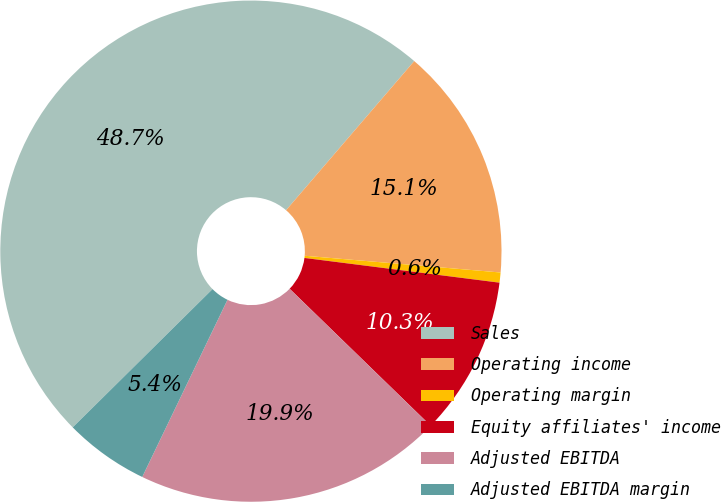Convert chart to OTSL. <chart><loc_0><loc_0><loc_500><loc_500><pie_chart><fcel>Sales<fcel>Operating income<fcel>Operating margin<fcel>Equity affiliates' income<fcel>Adjusted EBITDA<fcel>Adjusted EBITDA margin<nl><fcel>48.71%<fcel>15.06%<fcel>0.65%<fcel>10.26%<fcel>19.87%<fcel>5.45%<nl></chart> 